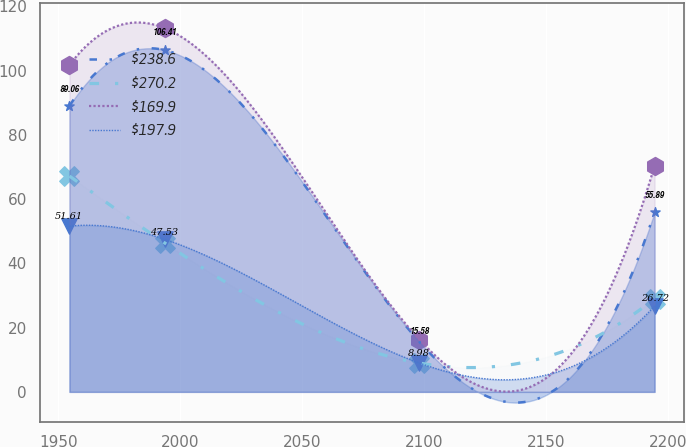Convert chart to OTSL. <chart><loc_0><loc_0><loc_500><loc_500><line_chart><ecel><fcel>$238.6<fcel>$270.2<fcel>$169.9<fcel>$197.9<nl><fcel>1954.58<fcel>89.06<fcel>67.18<fcel>101.75<fcel>51.61<nl><fcel>1993.57<fcel>106.41<fcel>46.38<fcel>113.24<fcel>47.53<nl><fcel>2097.98<fcel>15.58<fcel>8.98<fcel>16.3<fcel>8.98<nl><fcel>2194.37<fcel>55.89<fcel>29.04<fcel>70.38<fcel>26.72<nl></chart> 